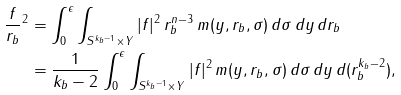<formula> <loc_0><loc_0><loc_500><loc_500>\| \frac { f } { r _ { b } } \| ^ { 2 } & = \int _ { 0 } ^ { \epsilon } \int _ { S ^ { k _ { b } - 1 } \times Y } | f | ^ { 2 } \, r _ { b } ^ { n - 3 } \, m ( y , r _ { b } , \sigma ) \, d \sigma \, d y \, d r _ { b } \\ & = \frac { 1 } { k _ { b } - 2 } \int _ { 0 } ^ { \epsilon } \int _ { S ^ { k _ { b } - 1 } \times Y } | f | ^ { 2 } \, m ( y , r _ { b } , \sigma ) \, d \sigma \, d y \, d ( r _ { b } ^ { k _ { b } - 2 } ) ,</formula> 